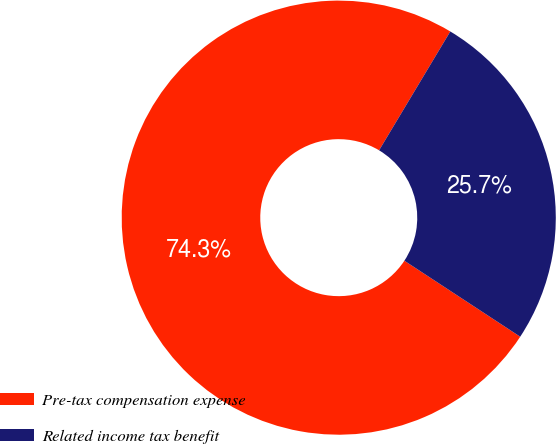Convert chart to OTSL. <chart><loc_0><loc_0><loc_500><loc_500><pie_chart><fcel>Pre-tax compensation expense<fcel>Related income tax benefit<nl><fcel>74.35%<fcel>25.65%<nl></chart> 